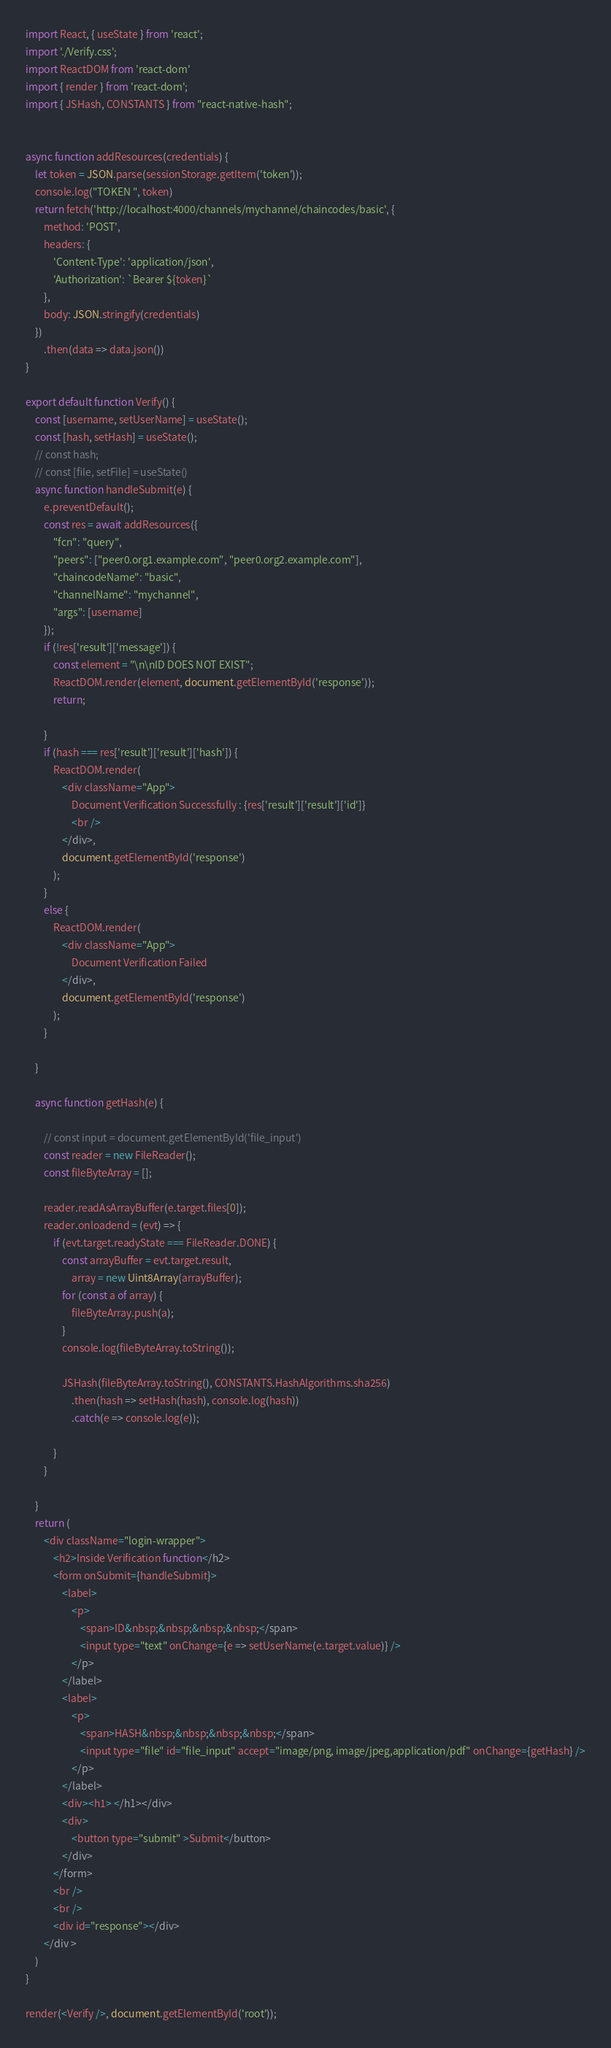Convert code to text. <code><loc_0><loc_0><loc_500><loc_500><_JavaScript_>import React, { useState } from 'react';
import './Verify.css';
import ReactDOM from 'react-dom'
import { render } from 'react-dom';
import { JSHash, CONSTANTS } from "react-native-hash";


async function addResources(credentials) {
    let token = JSON.parse(sessionStorage.getItem('token'));
    console.log("TOKEN ", token)
    return fetch('http://localhost:4000/channels/mychannel/chaincodes/basic', {
        method: 'POST',
        headers: {
            'Content-Type': 'application/json',
            'Authorization': `Bearer ${token}`
        },
        body: JSON.stringify(credentials)
    })
        .then(data => data.json())
}

export default function Verify() {
    const [username, setUserName] = useState();
    const [hash, setHash] = useState();
    // const hash;
    // const [file, setFile] = useState()
    async function handleSubmit(e) {
        e.preventDefault();
        const res = await addResources({
            "fcn": "query",
            "peers": ["peer0.org1.example.com", "peer0.org2.example.com"],
            "chaincodeName": "basic",
            "channelName": "mychannel",
            "args": [username]
        });
        if (!res['result']['message']) {
            const element = "\n\nID DOES NOT EXIST";
            ReactDOM.render(element, document.getElementById('response'));
            return;

        }
        if (hash === res['result']['result']['hash']) {
            ReactDOM.render(
                <div className="App">
                    Document Verification Successfully : {res['result']['result']['id']}
                    <br />
                </div>,
                document.getElementById('response')
            );
        }
        else {
            ReactDOM.render(
                <div className="App">
                    Document Verification Failed
                </div>,
                document.getElementById('response')
            );
        }

    }

    async function getHash(e) {

        // const input = document.getElementById('file_input')
        const reader = new FileReader();
        const fileByteArray = [];

        reader.readAsArrayBuffer(e.target.files[0]);
        reader.onloadend = (evt) => {
            if (evt.target.readyState === FileReader.DONE) {
                const arrayBuffer = evt.target.result,
                    array = new Uint8Array(arrayBuffer);
                for (const a of array) {
                    fileByteArray.push(a);
                }
                console.log(fileByteArray.toString());

                JSHash(fileByteArray.toString(), CONSTANTS.HashAlgorithms.sha256)
                    .then(hash => setHash(hash), console.log(hash))
                    .catch(e => console.log(e));

            }
        }

    }
    return (
        <div className="login-wrapper">
            <h2>Inside Verification function</h2>
            <form onSubmit={handleSubmit}>
                <label>
                    <p>
                        <span>ID&nbsp;&nbsp;&nbsp;&nbsp;</span>
                        <input type="text" onChange={e => setUserName(e.target.value)} />
                    </p>
                </label>
                <label>
                    <p>
                        <span>HASH&nbsp;&nbsp;&nbsp;&nbsp;</span>
                        <input type="file" id="file_input" accept="image/png, image/jpeg,application/pdf" onChange={getHash} />
                    </p>
                </label>
                <div><h1> </h1></div>
                <div>
                    <button type="submit" >Submit</button>
                </div>
            </form>
            <br />
            <br />
            <div id="response"></div>
        </div >
    )
}

render(<Verify />, document.getElementById('root'));

</code> 